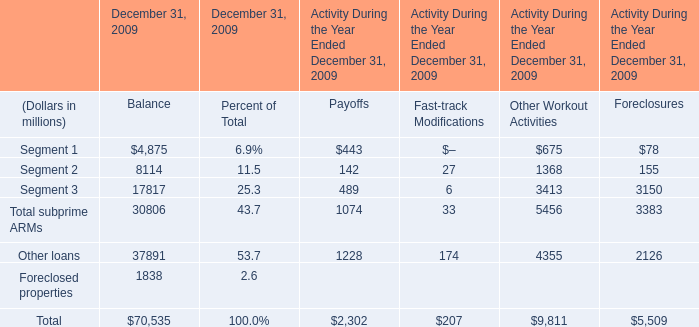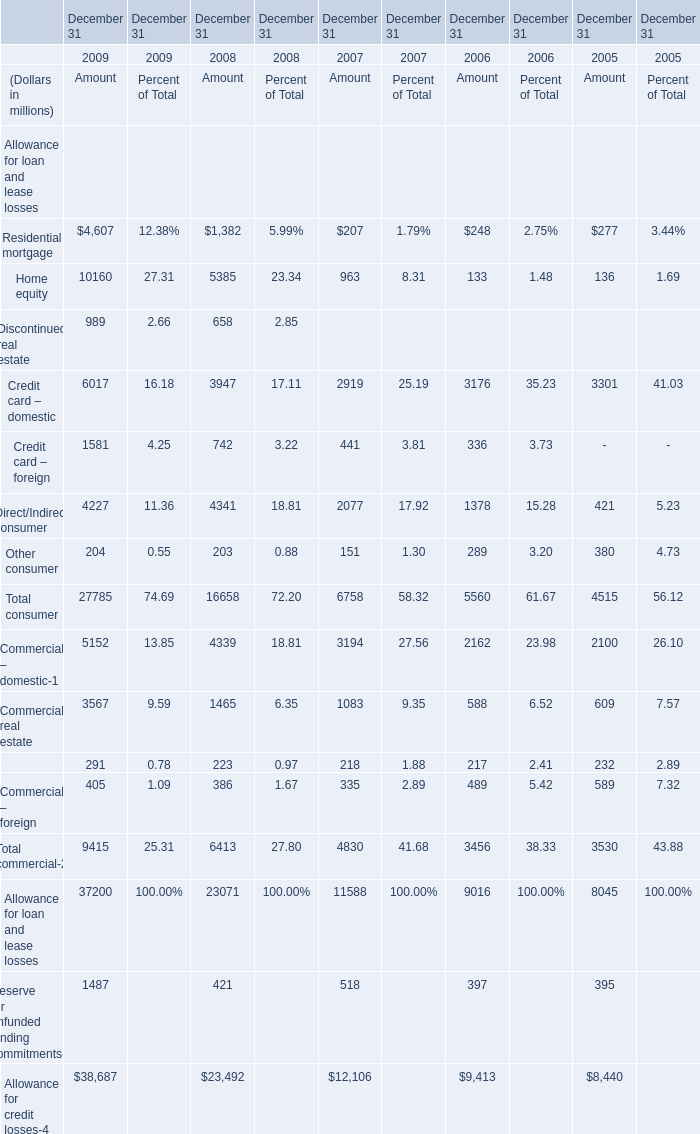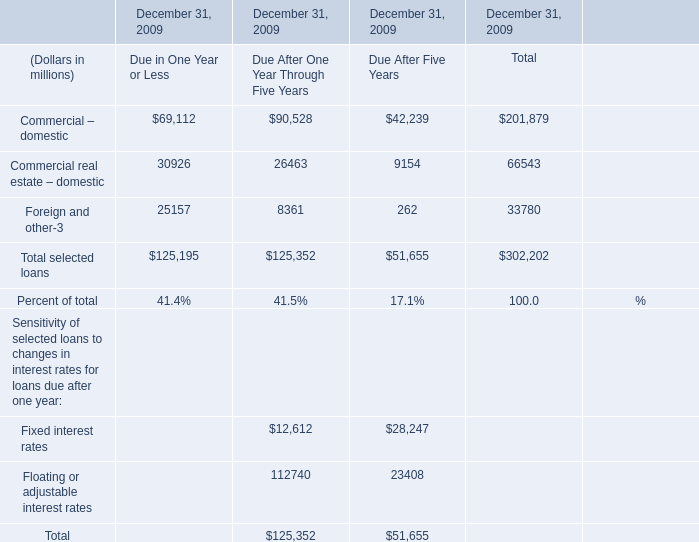What's the sum of Foreclosed properties of December 31, 2009 Balance, Home equity of December 31 2009 Amount, and Allowance for loan and lease losses of December 31 2009 Amount ? 
Computations: ((1838.0 + 10160.0) + 37200.0)
Answer: 49198.0. 